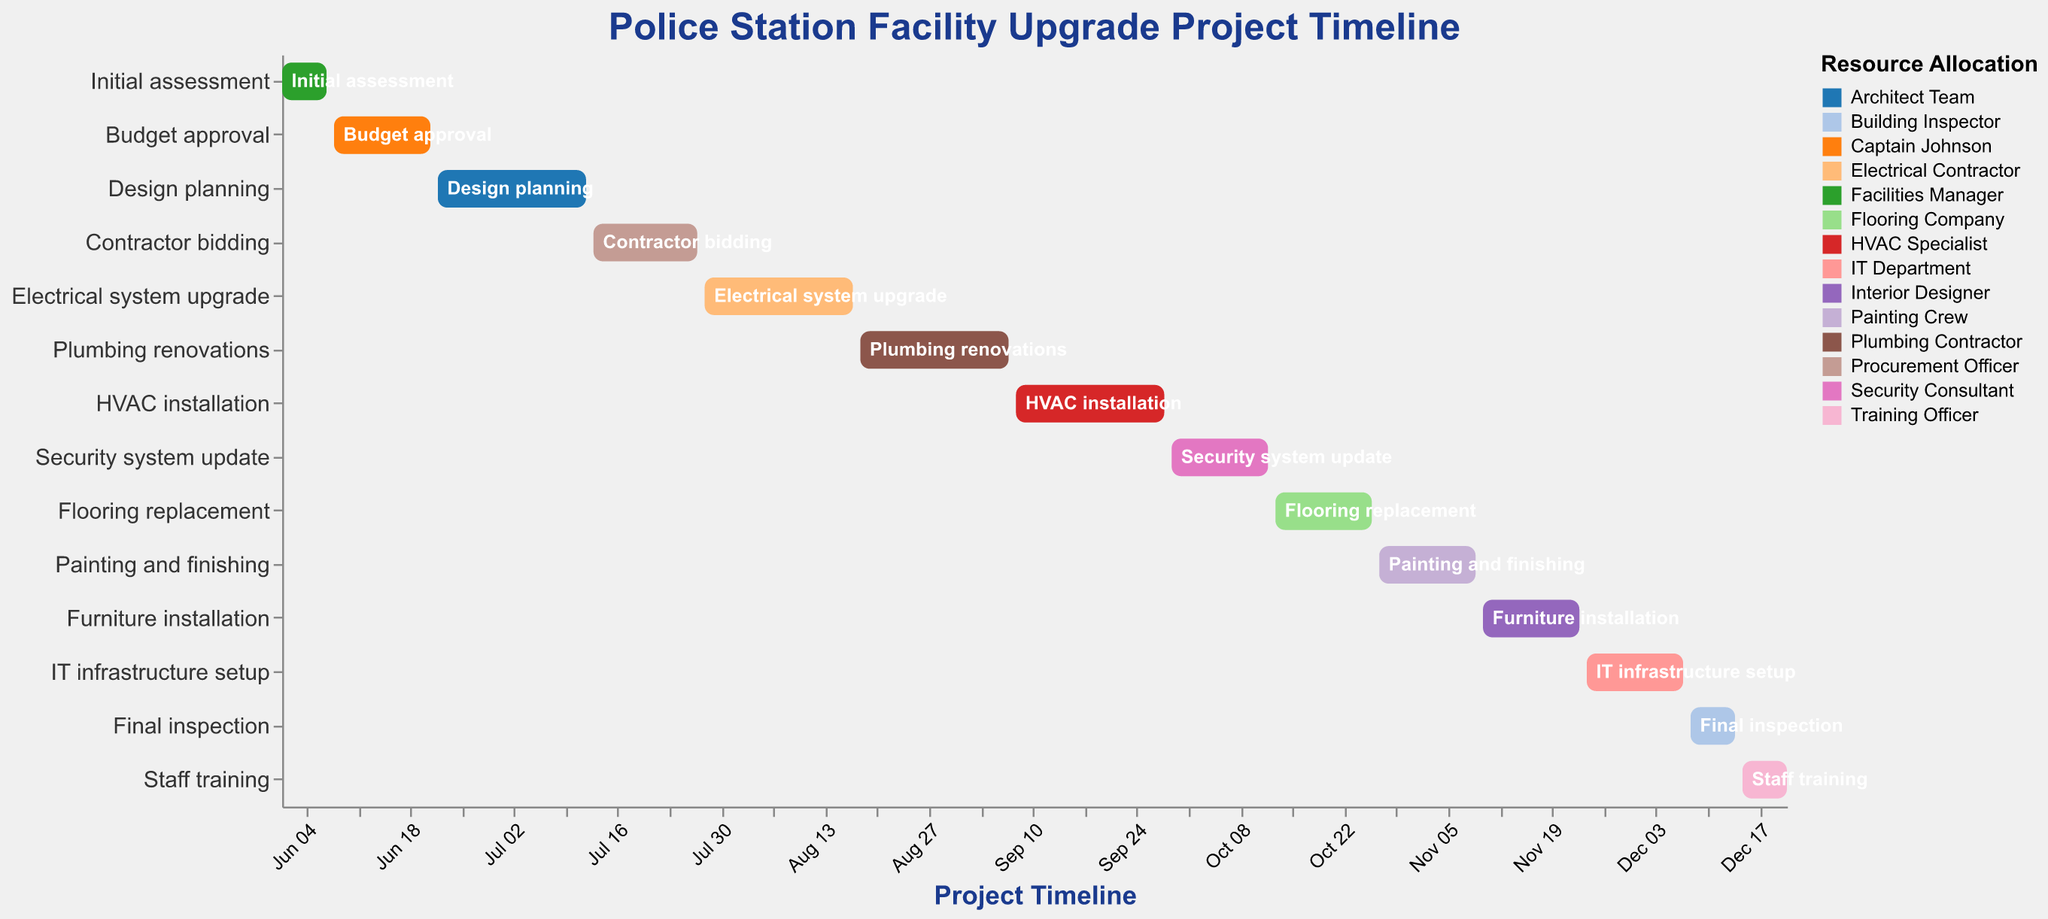What is the title of the figure? The title is usually found at the top of the figure in a larger and bold font. The figure clearly states the title as "Police Station Facility Upgrade Project Timeline".
Answer: Police Station Facility Upgrade Project Timeline Which task has the shortest duration? Glancing at the duration bar lengths and their labels, "Initial assessment", "Final inspection", and "Staff training" all have the shortest duration bars, spanning 7 days.
Answer: Initial assessment, Final inspection, and Staff training Which resource is responsible for the task starting the earliest? The task starting the earliest is the "Initial assessment" on June 1, 2023. The figure shows that the "Facilities Manager" is assigned to this task.
Answer: Facilities Manager What are the start and end dates for the "HVAC installation" task? Locate the "HVAC installation" bar and follow it to its starting and ending dates. The task starts on September 8, 2023, and ends on September 28, 2023.
Answer: September 8, 2023, to September 28, 2023 Which tasks are overlapping with the "Electrical system upgrade"? Identify the "Electrical system upgrade" task, which spans from July 28, 2023, to August 17, 2023. The overlapping tasks are those that share any dates within this range. "Contractor bidding", which ends on July 27, 2023, overlaps slightly. The "Plumbing renovations" task, starting on August 18, 2023, does not overlap.
Answer: Contractor bidding How many tasks, in total, are handled by the "Security Consultant"? Find the color and count the bars corresponding to the "Security Consultant". There is only one task assigned to this resource, the "Security system update".
Answer: 1 What is the total duration in days from the start of "Initial assessment" to the end of "Staff training"? The "Initial assessment" begins on June 1, 2023, and the "Staff training" ends on December 21, 2023. The total duration between these dates needs to be calculated, which is 204 days (counting actual days including weekends).
Answer: 204 days Which tasks have identical durations? Review the bar lengths and their labels. The tasks "Budget approval", "Security system update", "Flooring replacement", "Painting and finishing", "Furniture installation", and "IT infrastructure setup" all have the same duration of 14 days.
Answer: Budget approval, Security system update, Flooring replacement, Painting and finishing, Furniture installation, IT infrastructure setup What task follows immediately after the "Design planning"? Look at the sequence of the tasks. "Design planning" ends on July 12, 2023. The task that starts immediately after is "Contractor bidding", beginning on July 13, 2023.
Answer: Contractor bidding 